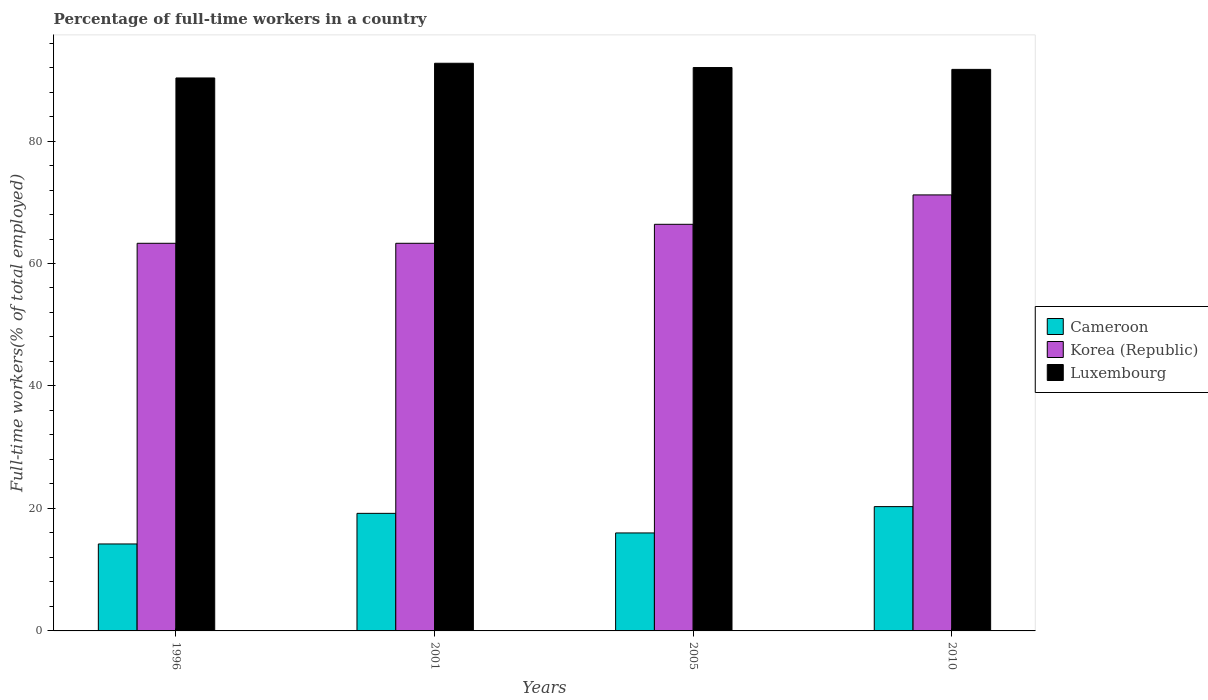Are the number of bars per tick equal to the number of legend labels?
Your response must be concise. Yes. Are the number of bars on each tick of the X-axis equal?
Provide a succinct answer. Yes. What is the label of the 3rd group of bars from the left?
Give a very brief answer. 2005. What is the percentage of full-time workers in Luxembourg in 2010?
Your answer should be very brief. 91.7. Across all years, what is the maximum percentage of full-time workers in Cameroon?
Your response must be concise. 20.3. Across all years, what is the minimum percentage of full-time workers in Cameroon?
Offer a very short reply. 14.2. In which year was the percentage of full-time workers in Cameroon minimum?
Offer a terse response. 1996. What is the total percentage of full-time workers in Cameroon in the graph?
Offer a terse response. 69.7. What is the difference between the percentage of full-time workers in Korea (Republic) in 2001 and that in 2005?
Ensure brevity in your answer.  -3.1. What is the difference between the percentage of full-time workers in Luxembourg in 2005 and the percentage of full-time workers in Korea (Republic) in 2001?
Make the answer very short. 28.7. What is the average percentage of full-time workers in Cameroon per year?
Offer a very short reply. 17.42. In the year 2001, what is the difference between the percentage of full-time workers in Cameroon and percentage of full-time workers in Luxembourg?
Make the answer very short. -73.5. In how many years, is the percentage of full-time workers in Korea (Republic) greater than 32 %?
Your answer should be compact. 4. What is the ratio of the percentage of full-time workers in Luxembourg in 2001 to that in 2010?
Your response must be concise. 1.01. Is the percentage of full-time workers in Luxembourg in 2001 less than that in 2005?
Give a very brief answer. No. Is the difference between the percentage of full-time workers in Cameroon in 2001 and 2005 greater than the difference between the percentage of full-time workers in Luxembourg in 2001 and 2005?
Ensure brevity in your answer.  Yes. What is the difference between the highest and the second highest percentage of full-time workers in Luxembourg?
Ensure brevity in your answer.  0.7. What is the difference between the highest and the lowest percentage of full-time workers in Korea (Republic)?
Offer a very short reply. 7.9. Is the sum of the percentage of full-time workers in Korea (Republic) in 1996 and 2001 greater than the maximum percentage of full-time workers in Luxembourg across all years?
Your answer should be compact. Yes. What does the 3rd bar from the left in 2010 represents?
Provide a short and direct response. Luxembourg. What does the 1st bar from the right in 2010 represents?
Your answer should be compact. Luxembourg. How many bars are there?
Your answer should be very brief. 12. How many years are there in the graph?
Ensure brevity in your answer.  4. What is the difference between two consecutive major ticks on the Y-axis?
Offer a terse response. 20. Are the values on the major ticks of Y-axis written in scientific E-notation?
Make the answer very short. No. What is the title of the graph?
Your response must be concise. Percentage of full-time workers in a country. Does "Lao PDR" appear as one of the legend labels in the graph?
Your answer should be compact. No. What is the label or title of the Y-axis?
Provide a short and direct response. Full-time workers(% of total employed). What is the Full-time workers(% of total employed) in Cameroon in 1996?
Offer a terse response. 14.2. What is the Full-time workers(% of total employed) of Korea (Republic) in 1996?
Provide a short and direct response. 63.3. What is the Full-time workers(% of total employed) of Luxembourg in 1996?
Your response must be concise. 90.3. What is the Full-time workers(% of total employed) of Cameroon in 2001?
Your response must be concise. 19.2. What is the Full-time workers(% of total employed) in Korea (Republic) in 2001?
Your response must be concise. 63.3. What is the Full-time workers(% of total employed) of Luxembourg in 2001?
Ensure brevity in your answer.  92.7. What is the Full-time workers(% of total employed) in Cameroon in 2005?
Make the answer very short. 16. What is the Full-time workers(% of total employed) in Korea (Republic) in 2005?
Provide a succinct answer. 66.4. What is the Full-time workers(% of total employed) of Luxembourg in 2005?
Keep it short and to the point. 92. What is the Full-time workers(% of total employed) of Cameroon in 2010?
Your response must be concise. 20.3. What is the Full-time workers(% of total employed) of Korea (Republic) in 2010?
Your answer should be very brief. 71.2. What is the Full-time workers(% of total employed) in Luxembourg in 2010?
Offer a very short reply. 91.7. Across all years, what is the maximum Full-time workers(% of total employed) of Cameroon?
Make the answer very short. 20.3. Across all years, what is the maximum Full-time workers(% of total employed) in Korea (Republic)?
Offer a very short reply. 71.2. Across all years, what is the maximum Full-time workers(% of total employed) of Luxembourg?
Your response must be concise. 92.7. Across all years, what is the minimum Full-time workers(% of total employed) in Cameroon?
Your answer should be very brief. 14.2. Across all years, what is the minimum Full-time workers(% of total employed) of Korea (Republic)?
Provide a succinct answer. 63.3. Across all years, what is the minimum Full-time workers(% of total employed) of Luxembourg?
Offer a terse response. 90.3. What is the total Full-time workers(% of total employed) in Cameroon in the graph?
Ensure brevity in your answer.  69.7. What is the total Full-time workers(% of total employed) of Korea (Republic) in the graph?
Offer a terse response. 264.2. What is the total Full-time workers(% of total employed) of Luxembourg in the graph?
Provide a succinct answer. 366.7. What is the difference between the Full-time workers(% of total employed) in Korea (Republic) in 1996 and that in 2001?
Offer a very short reply. 0. What is the difference between the Full-time workers(% of total employed) in Cameroon in 1996 and that in 2005?
Give a very brief answer. -1.8. What is the difference between the Full-time workers(% of total employed) in Cameroon in 1996 and that in 2010?
Your response must be concise. -6.1. What is the difference between the Full-time workers(% of total employed) of Korea (Republic) in 1996 and that in 2010?
Your answer should be compact. -7.9. What is the difference between the Full-time workers(% of total employed) of Korea (Republic) in 2001 and that in 2005?
Make the answer very short. -3.1. What is the difference between the Full-time workers(% of total employed) of Luxembourg in 2001 and that in 2005?
Offer a very short reply. 0.7. What is the difference between the Full-time workers(% of total employed) of Korea (Republic) in 2001 and that in 2010?
Offer a terse response. -7.9. What is the difference between the Full-time workers(% of total employed) in Luxembourg in 2001 and that in 2010?
Your answer should be compact. 1. What is the difference between the Full-time workers(% of total employed) of Korea (Republic) in 2005 and that in 2010?
Your answer should be compact. -4.8. What is the difference between the Full-time workers(% of total employed) in Luxembourg in 2005 and that in 2010?
Give a very brief answer. 0.3. What is the difference between the Full-time workers(% of total employed) in Cameroon in 1996 and the Full-time workers(% of total employed) in Korea (Republic) in 2001?
Your answer should be very brief. -49.1. What is the difference between the Full-time workers(% of total employed) of Cameroon in 1996 and the Full-time workers(% of total employed) of Luxembourg in 2001?
Offer a very short reply. -78.5. What is the difference between the Full-time workers(% of total employed) in Korea (Republic) in 1996 and the Full-time workers(% of total employed) in Luxembourg in 2001?
Ensure brevity in your answer.  -29.4. What is the difference between the Full-time workers(% of total employed) of Cameroon in 1996 and the Full-time workers(% of total employed) of Korea (Republic) in 2005?
Your response must be concise. -52.2. What is the difference between the Full-time workers(% of total employed) in Cameroon in 1996 and the Full-time workers(% of total employed) in Luxembourg in 2005?
Ensure brevity in your answer.  -77.8. What is the difference between the Full-time workers(% of total employed) of Korea (Republic) in 1996 and the Full-time workers(% of total employed) of Luxembourg in 2005?
Provide a succinct answer. -28.7. What is the difference between the Full-time workers(% of total employed) in Cameroon in 1996 and the Full-time workers(% of total employed) in Korea (Republic) in 2010?
Offer a very short reply. -57. What is the difference between the Full-time workers(% of total employed) in Cameroon in 1996 and the Full-time workers(% of total employed) in Luxembourg in 2010?
Your answer should be compact. -77.5. What is the difference between the Full-time workers(% of total employed) of Korea (Republic) in 1996 and the Full-time workers(% of total employed) of Luxembourg in 2010?
Your answer should be compact. -28.4. What is the difference between the Full-time workers(% of total employed) of Cameroon in 2001 and the Full-time workers(% of total employed) of Korea (Republic) in 2005?
Provide a succinct answer. -47.2. What is the difference between the Full-time workers(% of total employed) in Cameroon in 2001 and the Full-time workers(% of total employed) in Luxembourg in 2005?
Keep it short and to the point. -72.8. What is the difference between the Full-time workers(% of total employed) of Korea (Republic) in 2001 and the Full-time workers(% of total employed) of Luxembourg in 2005?
Make the answer very short. -28.7. What is the difference between the Full-time workers(% of total employed) of Cameroon in 2001 and the Full-time workers(% of total employed) of Korea (Republic) in 2010?
Offer a terse response. -52. What is the difference between the Full-time workers(% of total employed) in Cameroon in 2001 and the Full-time workers(% of total employed) in Luxembourg in 2010?
Keep it short and to the point. -72.5. What is the difference between the Full-time workers(% of total employed) in Korea (Republic) in 2001 and the Full-time workers(% of total employed) in Luxembourg in 2010?
Give a very brief answer. -28.4. What is the difference between the Full-time workers(% of total employed) in Cameroon in 2005 and the Full-time workers(% of total employed) in Korea (Republic) in 2010?
Ensure brevity in your answer.  -55.2. What is the difference between the Full-time workers(% of total employed) in Cameroon in 2005 and the Full-time workers(% of total employed) in Luxembourg in 2010?
Your answer should be compact. -75.7. What is the difference between the Full-time workers(% of total employed) in Korea (Republic) in 2005 and the Full-time workers(% of total employed) in Luxembourg in 2010?
Your answer should be very brief. -25.3. What is the average Full-time workers(% of total employed) in Cameroon per year?
Keep it short and to the point. 17.43. What is the average Full-time workers(% of total employed) of Korea (Republic) per year?
Your response must be concise. 66.05. What is the average Full-time workers(% of total employed) of Luxembourg per year?
Offer a terse response. 91.67. In the year 1996, what is the difference between the Full-time workers(% of total employed) of Cameroon and Full-time workers(% of total employed) of Korea (Republic)?
Offer a terse response. -49.1. In the year 1996, what is the difference between the Full-time workers(% of total employed) of Cameroon and Full-time workers(% of total employed) of Luxembourg?
Your response must be concise. -76.1. In the year 2001, what is the difference between the Full-time workers(% of total employed) of Cameroon and Full-time workers(% of total employed) of Korea (Republic)?
Your answer should be compact. -44.1. In the year 2001, what is the difference between the Full-time workers(% of total employed) in Cameroon and Full-time workers(% of total employed) in Luxembourg?
Offer a terse response. -73.5. In the year 2001, what is the difference between the Full-time workers(% of total employed) of Korea (Republic) and Full-time workers(% of total employed) of Luxembourg?
Ensure brevity in your answer.  -29.4. In the year 2005, what is the difference between the Full-time workers(% of total employed) in Cameroon and Full-time workers(% of total employed) in Korea (Republic)?
Give a very brief answer. -50.4. In the year 2005, what is the difference between the Full-time workers(% of total employed) in Cameroon and Full-time workers(% of total employed) in Luxembourg?
Your response must be concise. -76. In the year 2005, what is the difference between the Full-time workers(% of total employed) in Korea (Republic) and Full-time workers(% of total employed) in Luxembourg?
Provide a succinct answer. -25.6. In the year 2010, what is the difference between the Full-time workers(% of total employed) of Cameroon and Full-time workers(% of total employed) of Korea (Republic)?
Offer a terse response. -50.9. In the year 2010, what is the difference between the Full-time workers(% of total employed) of Cameroon and Full-time workers(% of total employed) of Luxembourg?
Your answer should be very brief. -71.4. In the year 2010, what is the difference between the Full-time workers(% of total employed) of Korea (Republic) and Full-time workers(% of total employed) of Luxembourg?
Offer a very short reply. -20.5. What is the ratio of the Full-time workers(% of total employed) in Cameroon in 1996 to that in 2001?
Make the answer very short. 0.74. What is the ratio of the Full-time workers(% of total employed) in Korea (Republic) in 1996 to that in 2001?
Offer a terse response. 1. What is the ratio of the Full-time workers(% of total employed) in Luxembourg in 1996 to that in 2001?
Provide a short and direct response. 0.97. What is the ratio of the Full-time workers(% of total employed) of Cameroon in 1996 to that in 2005?
Your answer should be compact. 0.89. What is the ratio of the Full-time workers(% of total employed) of Korea (Republic) in 1996 to that in 2005?
Keep it short and to the point. 0.95. What is the ratio of the Full-time workers(% of total employed) in Luxembourg in 1996 to that in 2005?
Your response must be concise. 0.98. What is the ratio of the Full-time workers(% of total employed) in Cameroon in 1996 to that in 2010?
Your answer should be very brief. 0.7. What is the ratio of the Full-time workers(% of total employed) in Korea (Republic) in 1996 to that in 2010?
Offer a very short reply. 0.89. What is the ratio of the Full-time workers(% of total employed) of Luxembourg in 1996 to that in 2010?
Offer a terse response. 0.98. What is the ratio of the Full-time workers(% of total employed) in Korea (Republic) in 2001 to that in 2005?
Ensure brevity in your answer.  0.95. What is the ratio of the Full-time workers(% of total employed) of Luxembourg in 2001 to that in 2005?
Your answer should be very brief. 1.01. What is the ratio of the Full-time workers(% of total employed) of Cameroon in 2001 to that in 2010?
Your response must be concise. 0.95. What is the ratio of the Full-time workers(% of total employed) of Korea (Republic) in 2001 to that in 2010?
Offer a terse response. 0.89. What is the ratio of the Full-time workers(% of total employed) of Luxembourg in 2001 to that in 2010?
Keep it short and to the point. 1.01. What is the ratio of the Full-time workers(% of total employed) in Cameroon in 2005 to that in 2010?
Your answer should be very brief. 0.79. What is the ratio of the Full-time workers(% of total employed) in Korea (Republic) in 2005 to that in 2010?
Make the answer very short. 0.93. What is the ratio of the Full-time workers(% of total employed) in Luxembourg in 2005 to that in 2010?
Your response must be concise. 1. What is the difference between the highest and the second highest Full-time workers(% of total employed) of Cameroon?
Provide a succinct answer. 1.1. What is the difference between the highest and the second highest Full-time workers(% of total employed) in Luxembourg?
Provide a short and direct response. 0.7. What is the difference between the highest and the lowest Full-time workers(% of total employed) in Luxembourg?
Your answer should be very brief. 2.4. 